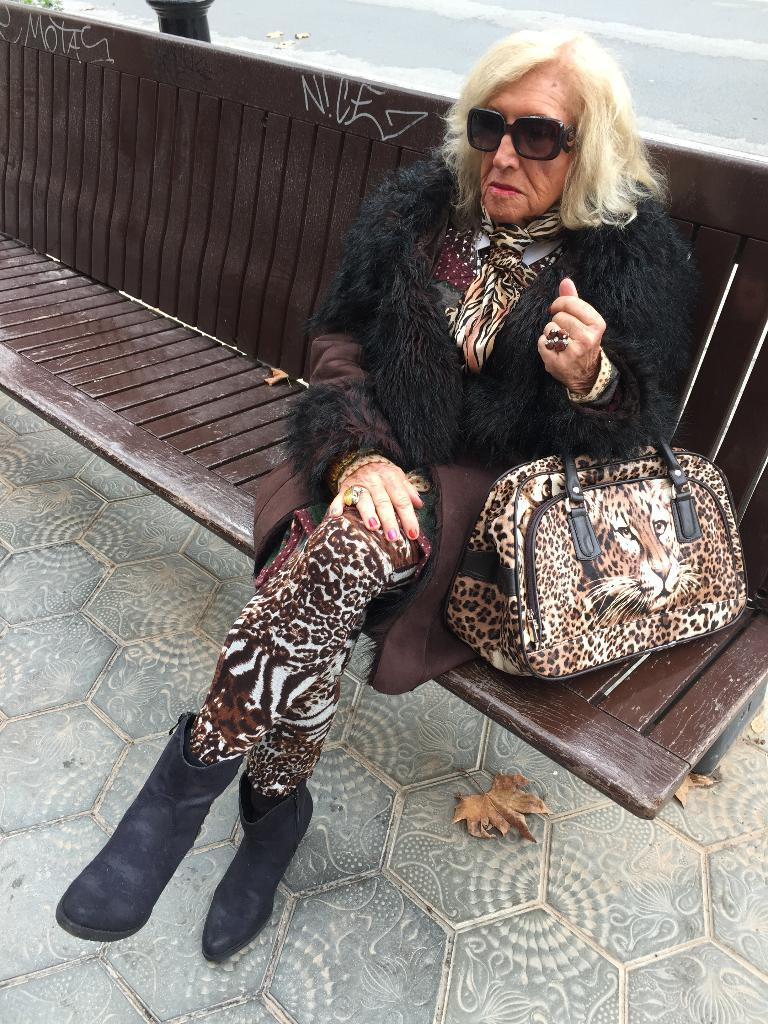Who is the main subject in the picture? There is an old woman in the picture. What is the woman doing in the image? The woman is sitting on a bench. What item does the woman have with her? The woman has a handbag. Can you describe the handbag? The handbag has a tiger face visible on it. What type of footwear is the woman wearing? The woman is wearing shoes. Does the woman have any accessories on her face? Yes, the woman is wearing spectacles. What type of gate can be seen in the image? There is no gate present in the image; it features an old woman sitting on a bench. What color is the woman's hair in the image? The facts provided do not mention the color of the woman's hair, so it cannot be determined from the image. 